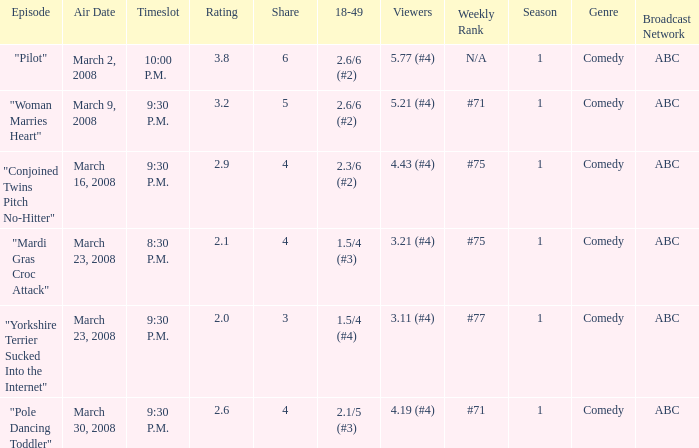What is the total ratings on share less than 4? 1.0. 